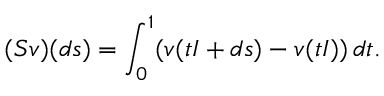<formula> <loc_0><loc_0><loc_500><loc_500>( S v ) ( d s ) = \int _ { 0 } ^ { 1 } ( v ( t I + d s ) - v ( t I ) ) \, d t .</formula> 